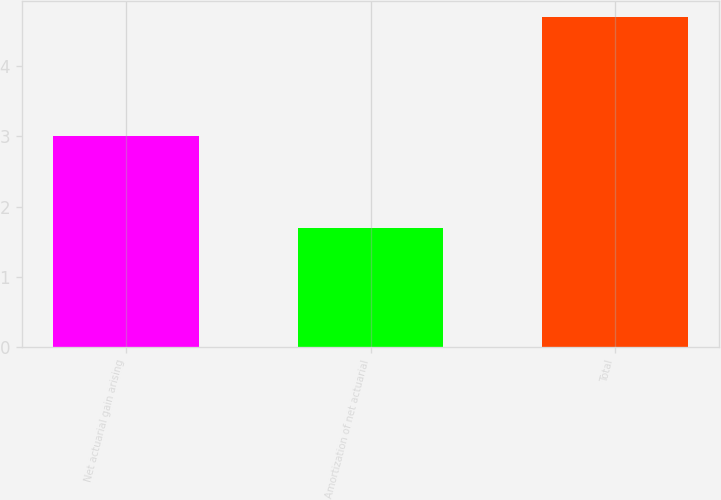Convert chart to OTSL. <chart><loc_0><loc_0><loc_500><loc_500><bar_chart><fcel>Net actuarial gain arising<fcel>Amortization of net actuarial<fcel>Total<nl><fcel>3<fcel>1.7<fcel>4.7<nl></chart> 